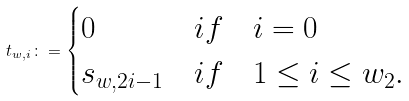<formula> <loc_0><loc_0><loc_500><loc_500>t _ { w , i } \colon = \begin{cases} 0 & i f \quad i = 0 \\ s _ { w , 2 i - 1 } & i f \quad 1 \leq i \leq w _ { 2 } . \end{cases}</formula> 